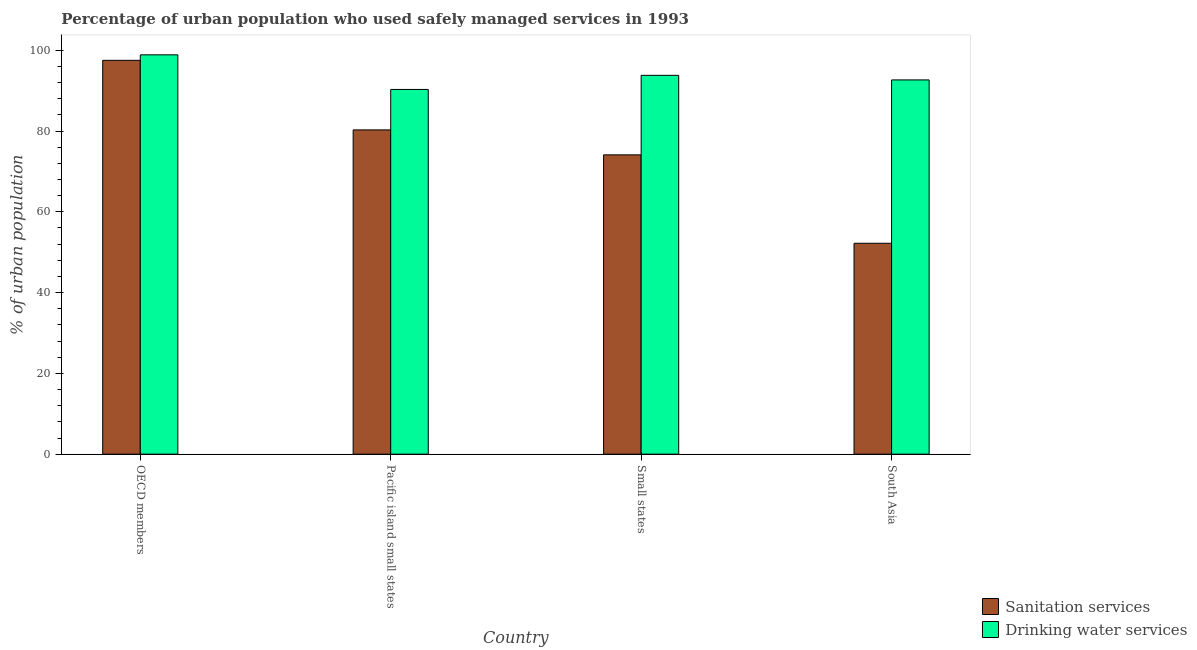How many different coloured bars are there?
Offer a very short reply. 2. How many bars are there on the 3rd tick from the right?
Keep it short and to the point. 2. What is the label of the 3rd group of bars from the left?
Ensure brevity in your answer.  Small states. What is the percentage of urban population who used sanitation services in Pacific island small states?
Make the answer very short. 80.27. Across all countries, what is the maximum percentage of urban population who used sanitation services?
Keep it short and to the point. 97.5. Across all countries, what is the minimum percentage of urban population who used drinking water services?
Ensure brevity in your answer.  90.29. In which country was the percentage of urban population who used sanitation services minimum?
Provide a succinct answer. South Asia. What is the total percentage of urban population who used drinking water services in the graph?
Provide a succinct answer. 375.57. What is the difference between the percentage of urban population who used sanitation services in OECD members and that in South Asia?
Provide a succinct answer. 45.29. What is the difference between the percentage of urban population who used drinking water services in Pacific island small states and the percentage of urban population who used sanitation services in South Asia?
Ensure brevity in your answer.  38.08. What is the average percentage of urban population who used sanitation services per country?
Your answer should be very brief. 76.02. What is the difference between the percentage of urban population who used sanitation services and percentage of urban population who used drinking water services in South Asia?
Provide a succinct answer. -40.44. In how many countries, is the percentage of urban population who used sanitation services greater than 40 %?
Keep it short and to the point. 4. What is the ratio of the percentage of urban population who used sanitation services in Pacific island small states to that in South Asia?
Offer a terse response. 1.54. Is the percentage of urban population who used sanitation services in Pacific island small states less than that in South Asia?
Provide a succinct answer. No. What is the difference between the highest and the second highest percentage of urban population who used drinking water services?
Offer a very short reply. 5.07. What is the difference between the highest and the lowest percentage of urban population who used sanitation services?
Offer a terse response. 45.29. In how many countries, is the percentage of urban population who used drinking water services greater than the average percentage of urban population who used drinking water services taken over all countries?
Offer a very short reply. 1. Is the sum of the percentage of urban population who used drinking water services in Pacific island small states and Small states greater than the maximum percentage of urban population who used sanitation services across all countries?
Make the answer very short. Yes. What does the 2nd bar from the left in OECD members represents?
Provide a short and direct response. Drinking water services. What does the 1st bar from the right in OECD members represents?
Keep it short and to the point. Drinking water services. How many bars are there?
Offer a terse response. 8. Are all the bars in the graph horizontal?
Your answer should be very brief. No. How many countries are there in the graph?
Your response must be concise. 4. Where does the legend appear in the graph?
Give a very brief answer. Bottom right. What is the title of the graph?
Your response must be concise. Percentage of urban population who used safely managed services in 1993. Does "Start a business" appear as one of the legend labels in the graph?
Offer a terse response. No. What is the label or title of the X-axis?
Make the answer very short. Country. What is the label or title of the Y-axis?
Provide a succinct answer. % of urban population. What is the % of urban population in Sanitation services in OECD members?
Your answer should be compact. 97.5. What is the % of urban population of Drinking water services in OECD members?
Keep it short and to the point. 98.86. What is the % of urban population of Sanitation services in Pacific island small states?
Your answer should be compact. 80.27. What is the % of urban population of Drinking water services in Pacific island small states?
Your answer should be very brief. 90.29. What is the % of urban population of Sanitation services in Small states?
Give a very brief answer. 74.1. What is the % of urban population in Drinking water services in Small states?
Offer a terse response. 93.78. What is the % of urban population of Sanitation services in South Asia?
Your answer should be very brief. 52.21. What is the % of urban population of Drinking water services in South Asia?
Offer a very short reply. 92.65. Across all countries, what is the maximum % of urban population in Sanitation services?
Keep it short and to the point. 97.5. Across all countries, what is the maximum % of urban population of Drinking water services?
Keep it short and to the point. 98.86. Across all countries, what is the minimum % of urban population in Sanitation services?
Provide a succinct answer. 52.21. Across all countries, what is the minimum % of urban population in Drinking water services?
Your response must be concise. 90.29. What is the total % of urban population in Sanitation services in the graph?
Offer a terse response. 304.08. What is the total % of urban population in Drinking water services in the graph?
Your answer should be compact. 375.57. What is the difference between the % of urban population in Sanitation services in OECD members and that in Pacific island small states?
Your answer should be very brief. 17.22. What is the difference between the % of urban population of Drinking water services in OECD members and that in Pacific island small states?
Keep it short and to the point. 8.56. What is the difference between the % of urban population in Sanitation services in OECD members and that in Small states?
Your response must be concise. 23.4. What is the difference between the % of urban population of Drinking water services in OECD members and that in Small states?
Keep it short and to the point. 5.07. What is the difference between the % of urban population of Sanitation services in OECD members and that in South Asia?
Ensure brevity in your answer.  45.29. What is the difference between the % of urban population of Drinking water services in OECD members and that in South Asia?
Give a very brief answer. 6.21. What is the difference between the % of urban population in Sanitation services in Pacific island small states and that in Small states?
Keep it short and to the point. 6.18. What is the difference between the % of urban population of Drinking water services in Pacific island small states and that in Small states?
Your answer should be very brief. -3.49. What is the difference between the % of urban population in Sanitation services in Pacific island small states and that in South Asia?
Give a very brief answer. 28.07. What is the difference between the % of urban population in Drinking water services in Pacific island small states and that in South Asia?
Your answer should be very brief. -2.36. What is the difference between the % of urban population in Sanitation services in Small states and that in South Asia?
Your response must be concise. 21.89. What is the difference between the % of urban population of Drinking water services in Small states and that in South Asia?
Provide a succinct answer. 1.13. What is the difference between the % of urban population in Sanitation services in OECD members and the % of urban population in Drinking water services in Pacific island small states?
Give a very brief answer. 7.21. What is the difference between the % of urban population of Sanitation services in OECD members and the % of urban population of Drinking water services in Small states?
Offer a terse response. 3.72. What is the difference between the % of urban population in Sanitation services in OECD members and the % of urban population in Drinking water services in South Asia?
Offer a terse response. 4.85. What is the difference between the % of urban population of Sanitation services in Pacific island small states and the % of urban population of Drinking water services in Small states?
Offer a terse response. -13.51. What is the difference between the % of urban population in Sanitation services in Pacific island small states and the % of urban population in Drinking water services in South Asia?
Ensure brevity in your answer.  -12.37. What is the difference between the % of urban population in Sanitation services in Small states and the % of urban population in Drinking water services in South Asia?
Keep it short and to the point. -18.55. What is the average % of urban population of Sanitation services per country?
Your response must be concise. 76.02. What is the average % of urban population in Drinking water services per country?
Make the answer very short. 93.89. What is the difference between the % of urban population of Sanitation services and % of urban population of Drinking water services in OECD members?
Give a very brief answer. -1.36. What is the difference between the % of urban population of Sanitation services and % of urban population of Drinking water services in Pacific island small states?
Offer a very short reply. -10.02. What is the difference between the % of urban population of Sanitation services and % of urban population of Drinking water services in Small states?
Keep it short and to the point. -19.69. What is the difference between the % of urban population in Sanitation services and % of urban population in Drinking water services in South Asia?
Give a very brief answer. -40.44. What is the ratio of the % of urban population of Sanitation services in OECD members to that in Pacific island small states?
Provide a succinct answer. 1.21. What is the ratio of the % of urban population in Drinking water services in OECD members to that in Pacific island small states?
Keep it short and to the point. 1.09. What is the ratio of the % of urban population in Sanitation services in OECD members to that in Small states?
Offer a terse response. 1.32. What is the ratio of the % of urban population of Drinking water services in OECD members to that in Small states?
Provide a short and direct response. 1.05. What is the ratio of the % of urban population of Sanitation services in OECD members to that in South Asia?
Your answer should be compact. 1.87. What is the ratio of the % of urban population of Drinking water services in OECD members to that in South Asia?
Make the answer very short. 1.07. What is the ratio of the % of urban population in Sanitation services in Pacific island small states to that in Small states?
Your answer should be very brief. 1.08. What is the ratio of the % of urban population of Drinking water services in Pacific island small states to that in Small states?
Your response must be concise. 0.96. What is the ratio of the % of urban population in Sanitation services in Pacific island small states to that in South Asia?
Offer a very short reply. 1.54. What is the ratio of the % of urban population in Drinking water services in Pacific island small states to that in South Asia?
Provide a short and direct response. 0.97. What is the ratio of the % of urban population of Sanitation services in Small states to that in South Asia?
Your answer should be very brief. 1.42. What is the ratio of the % of urban population in Drinking water services in Small states to that in South Asia?
Offer a terse response. 1.01. What is the difference between the highest and the second highest % of urban population in Sanitation services?
Your answer should be very brief. 17.22. What is the difference between the highest and the second highest % of urban population in Drinking water services?
Ensure brevity in your answer.  5.07. What is the difference between the highest and the lowest % of urban population of Sanitation services?
Make the answer very short. 45.29. What is the difference between the highest and the lowest % of urban population of Drinking water services?
Make the answer very short. 8.56. 